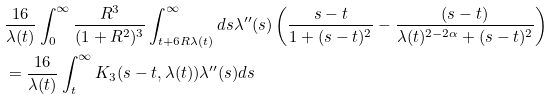<formula> <loc_0><loc_0><loc_500><loc_500>& \frac { 1 6 } { \lambda ( t ) } \int _ { 0 } ^ { \infty } \frac { R ^ { 3 } } { ( 1 + R ^ { 2 } ) ^ { 3 } } \int _ { t + 6 R \lambda ( t ) } ^ { \infty } d s \lambda ^ { \prime \prime } ( s ) \left ( \frac { s - t } { 1 + ( s - t ) ^ { 2 } } - \frac { ( s - t ) } { \lambda ( t ) ^ { 2 - 2 \alpha } + ( s - t ) ^ { 2 } } \right ) \\ & = \frac { 1 6 } { \lambda ( t ) } \int _ { t } ^ { \infty } K _ { 3 } ( s - t , \lambda ( t ) ) \lambda ^ { \prime \prime } ( s ) d s</formula> 